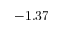Convert formula to latex. <formula><loc_0><loc_0><loc_500><loc_500>- 1 . 3 7</formula> 